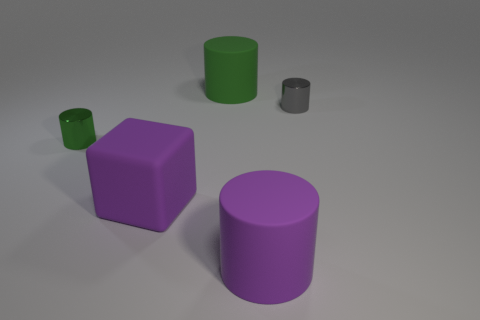Subtract 1 cylinders. How many cylinders are left? 3 Add 2 gray metallic objects. How many objects exist? 7 Subtract all cylinders. How many objects are left? 1 Add 5 big blue blocks. How many big blue blocks exist? 5 Subtract 0 blue cylinders. How many objects are left? 5 Subtract all large metallic balls. Subtract all green matte cylinders. How many objects are left? 4 Add 2 big purple cubes. How many big purple cubes are left? 3 